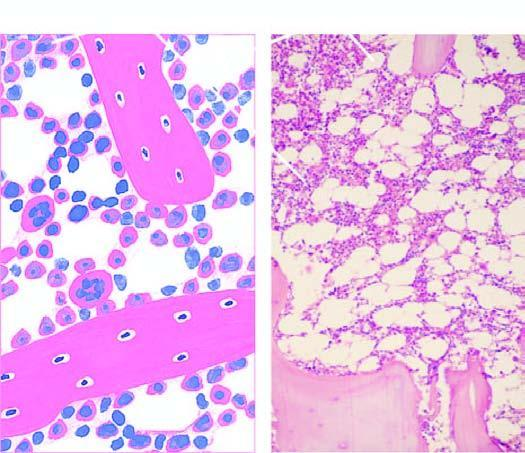s the nucleus fatty marrow?
Answer the question using a single word or phrase. No 